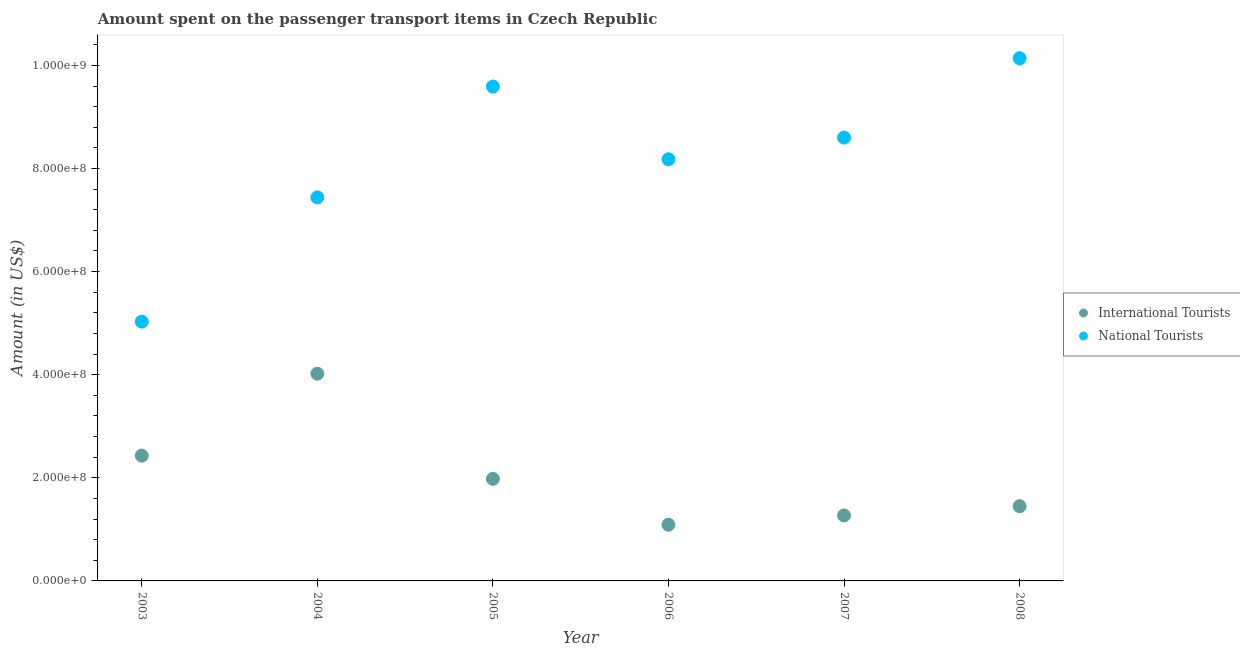What is the amount spent on transport items of national tourists in 2007?
Your answer should be compact. 8.60e+08. Across all years, what is the maximum amount spent on transport items of national tourists?
Offer a very short reply. 1.01e+09. Across all years, what is the minimum amount spent on transport items of national tourists?
Your answer should be very brief. 5.03e+08. In which year was the amount spent on transport items of international tourists maximum?
Keep it short and to the point. 2004. In which year was the amount spent on transport items of international tourists minimum?
Make the answer very short. 2006. What is the total amount spent on transport items of national tourists in the graph?
Ensure brevity in your answer.  4.90e+09. What is the difference between the amount spent on transport items of international tourists in 2005 and that in 2006?
Ensure brevity in your answer.  8.90e+07. What is the difference between the amount spent on transport items of national tourists in 2006 and the amount spent on transport items of international tourists in 2004?
Give a very brief answer. 4.16e+08. What is the average amount spent on transport items of national tourists per year?
Ensure brevity in your answer.  8.16e+08. In the year 2003, what is the difference between the amount spent on transport items of national tourists and amount spent on transport items of international tourists?
Ensure brevity in your answer.  2.60e+08. What is the ratio of the amount spent on transport items of national tourists in 2006 to that in 2008?
Your answer should be very brief. 0.81. Is the difference between the amount spent on transport items of national tourists in 2004 and 2005 greater than the difference between the amount spent on transport items of international tourists in 2004 and 2005?
Keep it short and to the point. No. What is the difference between the highest and the second highest amount spent on transport items of national tourists?
Ensure brevity in your answer.  5.50e+07. What is the difference between the highest and the lowest amount spent on transport items of international tourists?
Ensure brevity in your answer.  2.93e+08. Does the amount spent on transport items of national tourists monotonically increase over the years?
Provide a short and direct response. No. Is the amount spent on transport items of international tourists strictly less than the amount spent on transport items of national tourists over the years?
Offer a very short reply. Yes. How many years are there in the graph?
Your answer should be compact. 6. Are the values on the major ticks of Y-axis written in scientific E-notation?
Provide a succinct answer. Yes. Does the graph contain grids?
Your answer should be compact. No. What is the title of the graph?
Make the answer very short. Amount spent on the passenger transport items in Czech Republic. What is the label or title of the X-axis?
Provide a succinct answer. Year. What is the Amount (in US$) in International Tourists in 2003?
Keep it short and to the point. 2.43e+08. What is the Amount (in US$) in National Tourists in 2003?
Ensure brevity in your answer.  5.03e+08. What is the Amount (in US$) of International Tourists in 2004?
Your response must be concise. 4.02e+08. What is the Amount (in US$) of National Tourists in 2004?
Provide a short and direct response. 7.44e+08. What is the Amount (in US$) in International Tourists in 2005?
Your answer should be very brief. 1.98e+08. What is the Amount (in US$) of National Tourists in 2005?
Give a very brief answer. 9.59e+08. What is the Amount (in US$) of International Tourists in 2006?
Make the answer very short. 1.09e+08. What is the Amount (in US$) in National Tourists in 2006?
Give a very brief answer. 8.18e+08. What is the Amount (in US$) of International Tourists in 2007?
Ensure brevity in your answer.  1.27e+08. What is the Amount (in US$) of National Tourists in 2007?
Make the answer very short. 8.60e+08. What is the Amount (in US$) in International Tourists in 2008?
Your response must be concise. 1.45e+08. What is the Amount (in US$) of National Tourists in 2008?
Offer a terse response. 1.01e+09. Across all years, what is the maximum Amount (in US$) of International Tourists?
Your answer should be very brief. 4.02e+08. Across all years, what is the maximum Amount (in US$) of National Tourists?
Offer a terse response. 1.01e+09. Across all years, what is the minimum Amount (in US$) of International Tourists?
Make the answer very short. 1.09e+08. Across all years, what is the minimum Amount (in US$) of National Tourists?
Your answer should be compact. 5.03e+08. What is the total Amount (in US$) in International Tourists in the graph?
Your response must be concise. 1.22e+09. What is the total Amount (in US$) of National Tourists in the graph?
Give a very brief answer. 4.90e+09. What is the difference between the Amount (in US$) in International Tourists in 2003 and that in 2004?
Provide a succinct answer. -1.59e+08. What is the difference between the Amount (in US$) in National Tourists in 2003 and that in 2004?
Ensure brevity in your answer.  -2.41e+08. What is the difference between the Amount (in US$) in International Tourists in 2003 and that in 2005?
Offer a terse response. 4.50e+07. What is the difference between the Amount (in US$) in National Tourists in 2003 and that in 2005?
Your response must be concise. -4.56e+08. What is the difference between the Amount (in US$) of International Tourists in 2003 and that in 2006?
Your response must be concise. 1.34e+08. What is the difference between the Amount (in US$) in National Tourists in 2003 and that in 2006?
Keep it short and to the point. -3.15e+08. What is the difference between the Amount (in US$) in International Tourists in 2003 and that in 2007?
Keep it short and to the point. 1.16e+08. What is the difference between the Amount (in US$) of National Tourists in 2003 and that in 2007?
Provide a short and direct response. -3.57e+08. What is the difference between the Amount (in US$) in International Tourists in 2003 and that in 2008?
Keep it short and to the point. 9.80e+07. What is the difference between the Amount (in US$) in National Tourists in 2003 and that in 2008?
Keep it short and to the point. -5.11e+08. What is the difference between the Amount (in US$) of International Tourists in 2004 and that in 2005?
Provide a succinct answer. 2.04e+08. What is the difference between the Amount (in US$) in National Tourists in 2004 and that in 2005?
Offer a terse response. -2.15e+08. What is the difference between the Amount (in US$) of International Tourists in 2004 and that in 2006?
Provide a succinct answer. 2.93e+08. What is the difference between the Amount (in US$) in National Tourists in 2004 and that in 2006?
Provide a succinct answer. -7.40e+07. What is the difference between the Amount (in US$) of International Tourists in 2004 and that in 2007?
Offer a terse response. 2.75e+08. What is the difference between the Amount (in US$) in National Tourists in 2004 and that in 2007?
Keep it short and to the point. -1.16e+08. What is the difference between the Amount (in US$) in International Tourists in 2004 and that in 2008?
Provide a short and direct response. 2.57e+08. What is the difference between the Amount (in US$) of National Tourists in 2004 and that in 2008?
Provide a succinct answer. -2.70e+08. What is the difference between the Amount (in US$) of International Tourists in 2005 and that in 2006?
Give a very brief answer. 8.90e+07. What is the difference between the Amount (in US$) in National Tourists in 2005 and that in 2006?
Offer a very short reply. 1.41e+08. What is the difference between the Amount (in US$) in International Tourists in 2005 and that in 2007?
Provide a short and direct response. 7.10e+07. What is the difference between the Amount (in US$) of National Tourists in 2005 and that in 2007?
Offer a terse response. 9.90e+07. What is the difference between the Amount (in US$) of International Tourists in 2005 and that in 2008?
Your answer should be compact. 5.30e+07. What is the difference between the Amount (in US$) of National Tourists in 2005 and that in 2008?
Your answer should be very brief. -5.50e+07. What is the difference between the Amount (in US$) of International Tourists in 2006 and that in 2007?
Make the answer very short. -1.80e+07. What is the difference between the Amount (in US$) of National Tourists in 2006 and that in 2007?
Your answer should be very brief. -4.20e+07. What is the difference between the Amount (in US$) of International Tourists in 2006 and that in 2008?
Give a very brief answer. -3.60e+07. What is the difference between the Amount (in US$) of National Tourists in 2006 and that in 2008?
Offer a very short reply. -1.96e+08. What is the difference between the Amount (in US$) in International Tourists in 2007 and that in 2008?
Provide a short and direct response. -1.80e+07. What is the difference between the Amount (in US$) in National Tourists in 2007 and that in 2008?
Give a very brief answer. -1.54e+08. What is the difference between the Amount (in US$) in International Tourists in 2003 and the Amount (in US$) in National Tourists in 2004?
Give a very brief answer. -5.01e+08. What is the difference between the Amount (in US$) of International Tourists in 2003 and the Amount (in US$) of National Tourists in 2005?
Offer a terse response. -7.16e+08. What is the difference between the Amount (in US$) of International Tourists in 2003 and the Amount (in US$) of National Tourists in 2006?
Your response must be concise. -5.75e+08. What is the difference between the Amount (in US$) of International Tourists in 2003 and the Amount (in US$) of National Tourists in 2007?
Provide a succinct answer. -6.17e+08. What is the difference between the Amount (in US$) of International Tourists in 2003 and the Amount (in US$) of National Tourists in 2008?
Ensure brevity in your answer.  -7.71e+08. What is the difference between the Amount (in US$) of International Tourists in 2004 and the Amount (in US$) of National Tourists in 2005?
Offer a terse response. -5.57e+08. What is the difference between the Amount (in US$) in International Tourists in 2004 and the Amount (in US$) in National Tourists in 2006?
Keep it short and to the point. -4.16e+08. What is the difference between the Amount (in US$) in International Tourists in 2004 and the Amount (in US$) in National Tourists in 2007?
Ensure brevity in your answer.  -4.58e+08. What is the difference between the Amount (in US$) in International Tourists in 2004 and the Amount (in US$) in National Tourists in 2008?
Your response must be concise. -6.12e+08. What is the difference between the Amount (in US$) of International Tourists in 2005 and the Amount (in US$) of National Tourists in 2006?
Your answer should be very brief. -6.20e+08. What is the difference between the Amount (in US$) of International Tourists in 2005 and the Amount (in US$) of National Tourists in 2007?
Your response must be concise. -6.62e+08. What is the difference between the Amount (in US$) in International Tourists in 2005 and the Amount (in US$) in National Tourists in 2008?
Ensure brevity in your answer.  -8.16e+08. What is the difference between the Amount (in US$) in International Tourists in 2006 and the Amount (in US$) in National Tourists in 2007?
Give a very brief answer. -7.51e+08. What is the difference between the Amount (in US$) in International Tourists in 2006 and the Amount (in US$) in National Tourists in 2008?
Make the answer very short. -9.05e+08. What is the difference between the Amount (in US$) in International Tourists in 2007 and the Amount (in US$) in National Tourists in 2008?
Keep it short and to the point. -8.87e+08. What is the average Amount (in US$) of International Tourists per year?
Make the answer very short. 2.04e+08. What is the average Amount (in US$) in National Tourists per year?
Give a very brief answer. 8.16e+08. In the year 2003, what is the difference between the Amount (in US$) in International Tourists and Amount (in US$) in National Tourists?
Give a very brief answer. -2.60e+08. In the year 2004, what is the difference between the Amount (in US$) of International Tourists and Amount (in US$) of National Tourists?
Give a very brief answer. -3.42e+08. In the year 2005, what is the difference between the Amount (in US$) of International Tourists and Amount (in US$) of National Tourists?
Provide a succinct answer. -7.61e+08. In the year 2006, what is the difference between the Amount (in US$) in International Tourists and Amount (in US$) in National Tourists?
Your answer should be very brief. -7.09e+08. In the year 2007, what is the difference between the Amount (in US$) of International Tourists and Amount (in US$) of National Tourists?
Offer a very short reply. -7.33e+08. In the year 2008, what is the difference between the Amount (in US$) in International Tourists and Amount (in US$) in National Tourists?
Keep it short and to the point. -8.69e+08. What is the ratio of the Amount (in US$) of International Tourists in 2003 to that in 2004?
Provide a short and direct response. 0.6. What is the ratio of the Amount (in US$) of National Tourists in 2003 to that in 2004?
Keep it short and to the point. 0.68. What is the ratio of the Amount (in US$) in International Tourists in 2003 to that in 2005?
Your answer should be compact. 1.23. What is the ratio of the Amount (in US$) in National Tourists in 2003 to that in 2005?
Offer a terse response. 0.52. What is the ratio of the Amount (in US$) in International Tourists in 2003 to that in 2006?
Ensure brevity in your answer.  2.23. What is the ratio of the Amount (in US$) of National Tourists in 2003 to that in 2006?
Make the answer very short. 0.61. What is the ratio of the Amount (in US$) in International Tourists in 2003 to that in 2007?
Your answer should be compact. 1.91. What is the ratio of the Amount (in US$) in National Tourists in 2003 to that in 2007?
Offer a terse response. 0.58. What is the ratio of the Amount (in US$) of International Tourists in 2003 to that in 2008?
Offer a terse response. 1.68. What is the ratio of the Amount (in US$) in National Tourists in 2003 to that in 2008?
Provide a succinct answer. 0.5. What is the ratio of the Amount (in US$) in International Tourists in 2004 to that in 2005?
Ensure brevity in your answer.  2.03. What is the ratio of the Amount (in US$) of National Tourists in 2004 to that in 2005?
Offer a terse response. 0.78. What is the ratio of the Amount (in US$) of International Tourists in 2004 to that in 2006?
Give a very brief answer. 3.69. What is the ratio of the Amount (in US$) of National Tourists in 2004 to that in 2006?
Provide a succinct answer. 0.91. What is the ratio of the Amount (in US$) of International Tourists in 2004 to that in 2007?
Provide a succinct answer. 3.17. What is the ratio of the Amount (in US$) of National Tourists in 2004 to that in 2007?
Provide a short and direct response. 0.87. What is the ratio of the Amount (in US$) of International Tourists in 2004 to that in 2008?
Your answer should be compact. 2.77. What is the ratio of the Amount (in US$) of National Tourists in 2004 to that in 2008?
Offer a very short reply. 0.73. What is the ratio of the Amount (in US$) in International Tourists in 2005 to that in 2006?
Keep it short and to the point. 1.82. What is the ratio of the Amount (in US$) of National Tourists in 2005 to that in 2006?
Ensure brevity in your answer.  1.17. What is the ratio of the Amount (in US$) in International Tourists in 2005 to that in 2007?
Offer a very short reply. 1.56. What is the ratio of the Amount (in US$) in National Tourists in 2005 to that in 2007?
Your answer should be very brief. 1.12. What is the ratio of the Amount (in US$) in International Tourists in 2005 to that in 2008?
Your answer should be compact. 1.37. What is the ratio of the Amount (in US$) in National Tourists in 2005 to that in 2008?
Your answer should be very brief. 0.95. What is the ratio of the Amount (in US$) in International Tourists in 2006 to that in 2007?
Keep it short and to the point. 0.86. What is the ratio of the Amount (in US$) in National Tourists in 2006 to that in 2007?
Provide a short and direct response. 0.95. What is the ratio of the Amount (in US$) of International Tourists in 2006 to that in 2008?
Ensure brevity in your answer.  0.75. What is the ratio of the Amount (in US$) in National Tourists in 2006 to that in 2008?
Offer a terse response. 0.81. What is the ratio of the Amount (in US$) of International Tourists in 2007 to that in 2008?
Your answer should be very brief. 0.88. What is the ratio of the Amount (in US$) in National Tourists in 2007 to that in 2008?
Ensure brevity in your answer.  0.85. What is the difference between the highest and the second highest Amount (in US$) of International Tourists?
Ensure brevity in your answer.  1.59e+08. What is the difference between the highest and the second highest Amount (in US$) in National Tourists?
Provide a succinct answer. 5.50e+07. What is the difference between the highest and the lowest Amount (in US$) of International Tourists?
Your answer should be compact. 2.93e+08. What is the difference between the highest and the lowest Amount (in US$) of National Tourists?
Provide a succinct answer. 5.11e+08. 